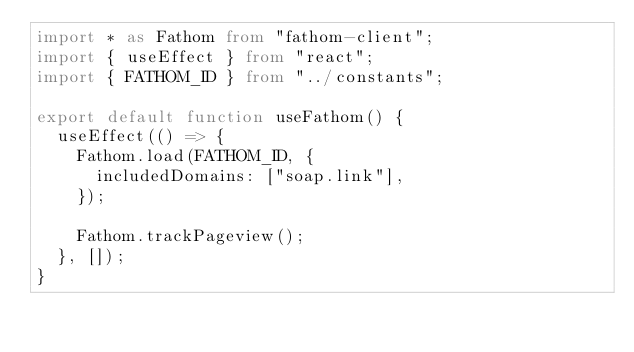Convert code to text. <code><loc_0><loc_0><loc_500><loc_500><_TypeScript_>import * as Fathom from "fathom-client";
import { useEffect } from "react";
import { FATHOM_ID } from "../constants";

export default function useFathom() {
  useEffect(() => {
    Fathom.load(FATHOM_ID, {
      includedDomains: ["soap.link"],
    });

    Fathom.trackPageview();
  }, []);
}
</code> 